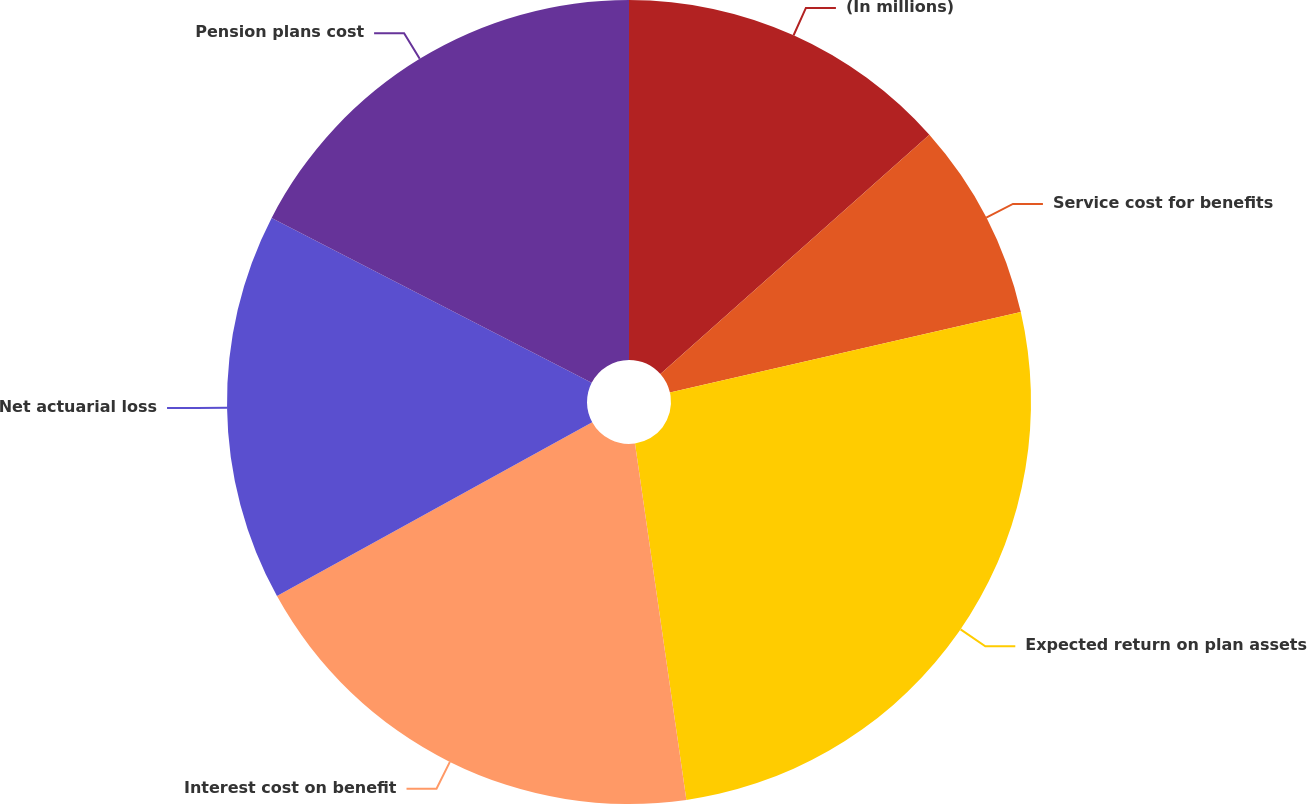<chart> <loc_0><loc_0><loc_500><loc_500><pie_chart><fcel>(In millions)<fcel>Service cost for benefits<fcel>Expected return on plan assets<fcel>Interest cost on benefit<fcel>Net actuarial loss<fcel>Pension plans cost<nl><fcel>13.43%<fcel>7.98%<fcel>26.31%<fcel>19.26%<fcel>15.59%<fcel>17.43%<nl></chart> 